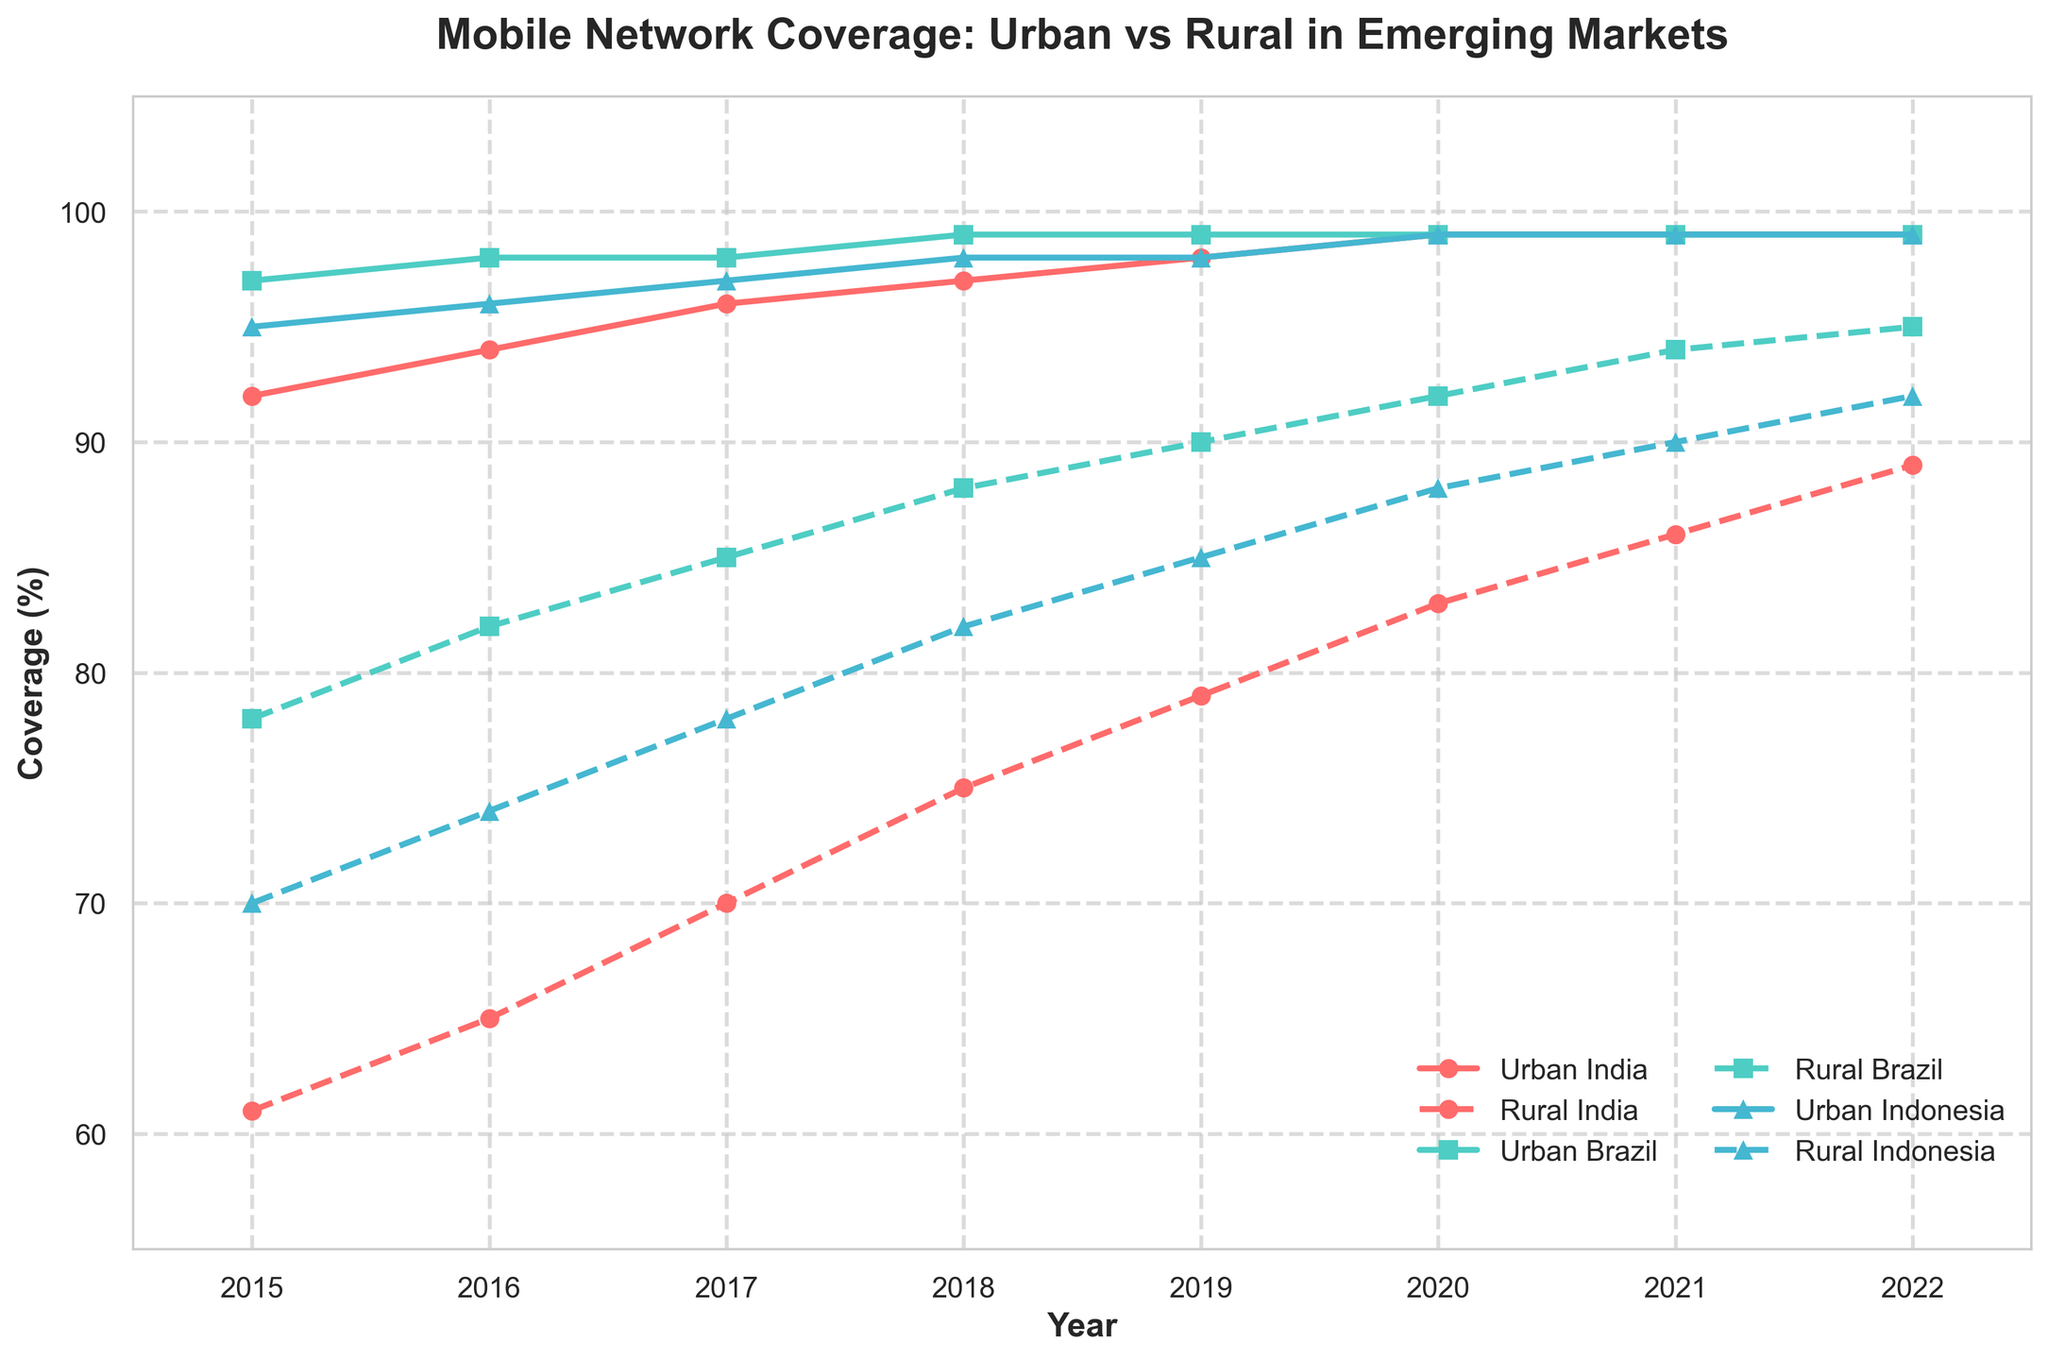What was the Urban mobile network coverage in Brazil in 2019? Check the plotted line for Urban Brazil at the year 2019. The plot shows the coverage at this point.
Answer: 99% Which country had the highest Rural mobile network coverage in 2020? Check the plotted lines for Rural India, Rural Brazil, and Rural Indonesia and observe the coverage percentages at the year 2020. Identify the highest one.
Answer: Brazil Was the Urban mobile network coverage in Indonesia ever less than 95%? Trace the plotted line for Urban Indonesia and see if it ever dips below 95% at any point in time.
Answer: No How much did the Rural mobile network coverage percentage increase in Indonesia from 2015 to 2022? Subtract the Rural Indonesia coverage percentage in 2015 from the percentage in 2022: 92 - 70
Answer: 22% Which year shows equal Urban and Rural mobile network coverage in Brazil? Compare the two lines for Brazil and check if they overlap at any year.
Answer: 2015 What was the difference in Urban mobile network coverage between Brazil and India in 2016? Subtract the Urban coverage percentage of India from that of Brazil for the year 2016: 98 - 94
Answer: 4% Which country had the smallest difference between Urban and Rural mobile network coverage in 2017? Check the differences between Urban and Rural coverage percentages for each country in 2017 and identify the smallest difference.
Answer: Brazil For which country did Rural mobile network coverage improve the most from 2015 to 2022? Compare the change (improvement) in Rural coverage from 2015 to 2022 for each country. Indonesia: 92-70, Brazil: 95-78, India: 89-61.
Answer: India What was the average Urban mobile network coverage for India from 2015 to 2022? Sum up the Urban coverage percentages for India over the years and divide by the number of years: (92 + 94 + 96 + 97 + 98 + 99 + 99 + 99) / 8.
Answer: 96.75% Which country had continuous improvement in Rural mobile network coverage from 2015 to 2022? Check each year's data for all countries and see which one shows an uninterrupted increase in Rural network coverage throughout the period.
Answer: India 